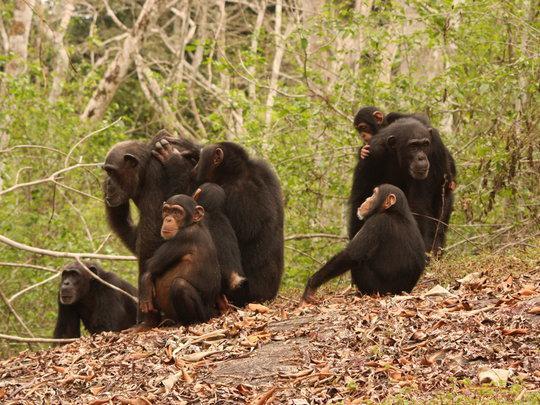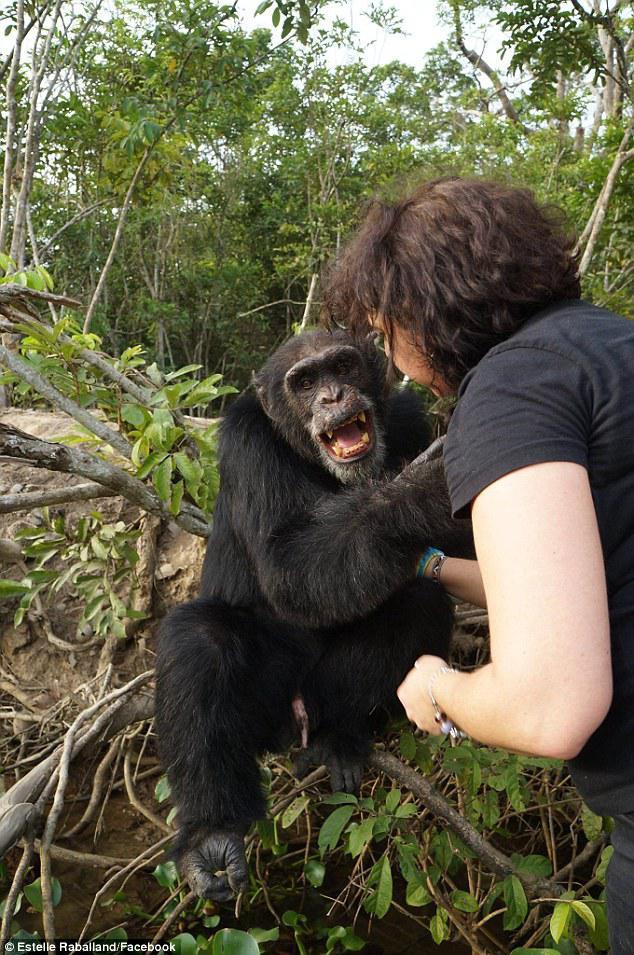The first image is the image on the left, the second image is the image on the right. Examine the images to the left and right. Is the description "There are three or fewer apes in total." accurate? Answer yes or no. No. The first image is the image on the left, the second image is the image on the right. Evaluate the accuracy of this statement regarding the images: "The left image contains exactly two chimpanzees.". Is it true? Answer yes or no. No. 